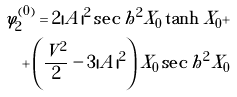<formula> <loc_0><loc_0><loc_500><loc_500>\varphi _ { 2 } ^ { ( 0 ) } = 2 | A | ^ { 2 } \sec h ^ { 2 } X _ { 0 } \tanh X _ { 0 } + \\ + \left ( \frac { V ^ { 2 } } { 2 } - 3 | A | ^ { 2 } \right ) X _ { 0 } \sec h ^ { 2 } X _ { 0 }</formula> 